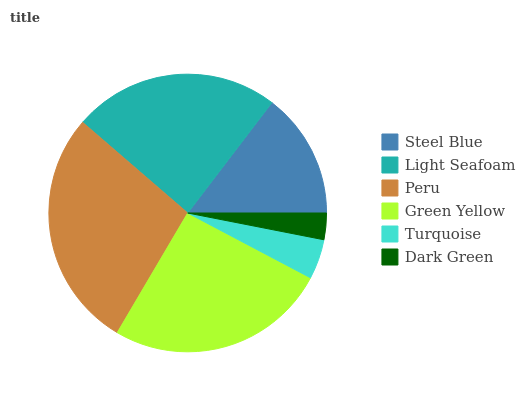Is Dark Green the minimum?
Answer yes or no. Yes. Is Peru the maximum?
Answer yes or no. Yes. Is Light Seafoam the minimum?
Answer yes or no. No. Is Light Seafoam the maximum?
Answer yes or no. No. Is Light Seafoam greater than Steel Blue?
Answer yes or no. Yes. Is Steel Blue less than Light Seafoam?
Answer yes or no. Yes. Is Steel Blue greater than Light Seafoam?
Answer yes or no. No. Is Light Seafoam less than Steel Blue?
Answer yes or no. No. Is Light Seafoam the high median?
Answer yes or no. Yes. Is Steel Blue the low median?
Answer yes or no. Yes. Is Turquoise the high median?
Answer yes or no. No. Is Peru the low median?
Answer yes or no. No. 